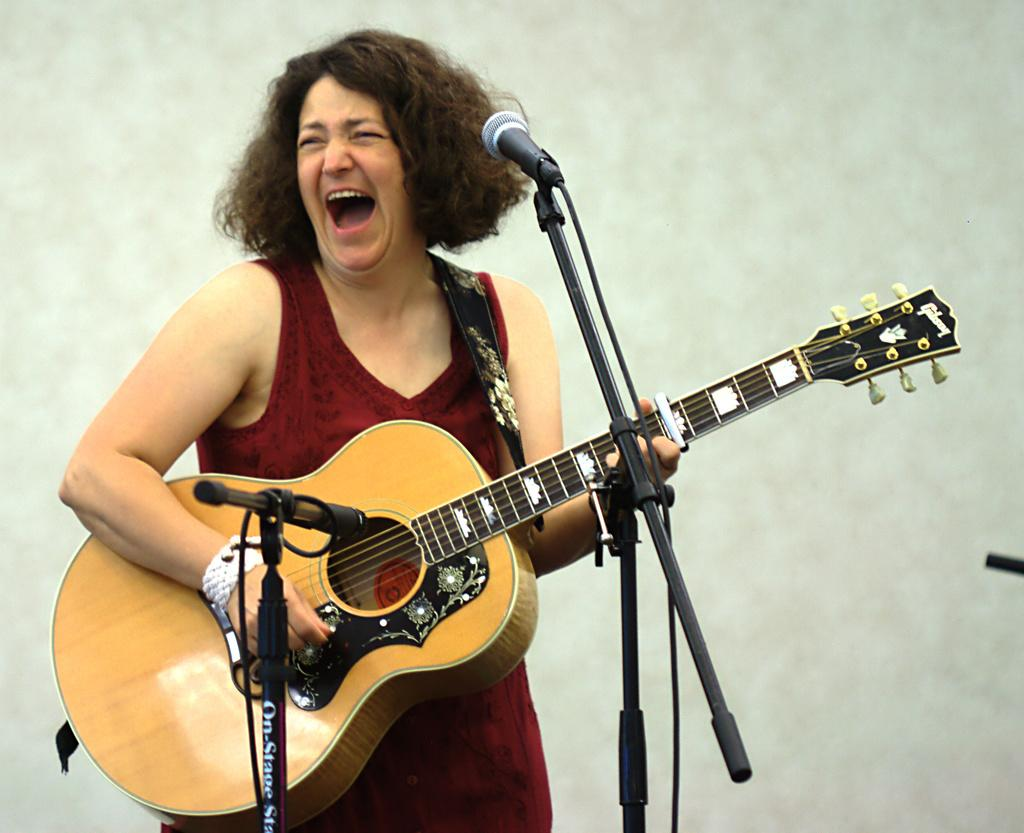What is the main subject of the image? The main subject of the image is a woman. What is the woman doing in the image? The woman is standing and playing a guitar. What object is present in the image that is typically used for amplifying sound? There is a microphone in the image, and it is attached to a microphone stand. What degree does the woman have in the image? There is no information about the woman's degree in the image. Can you provide an example of another instrument the woman might be playing in the image? The image only shows the woman playing a guitar, so it is not possible to provide an example of another instrument she might be playing. 